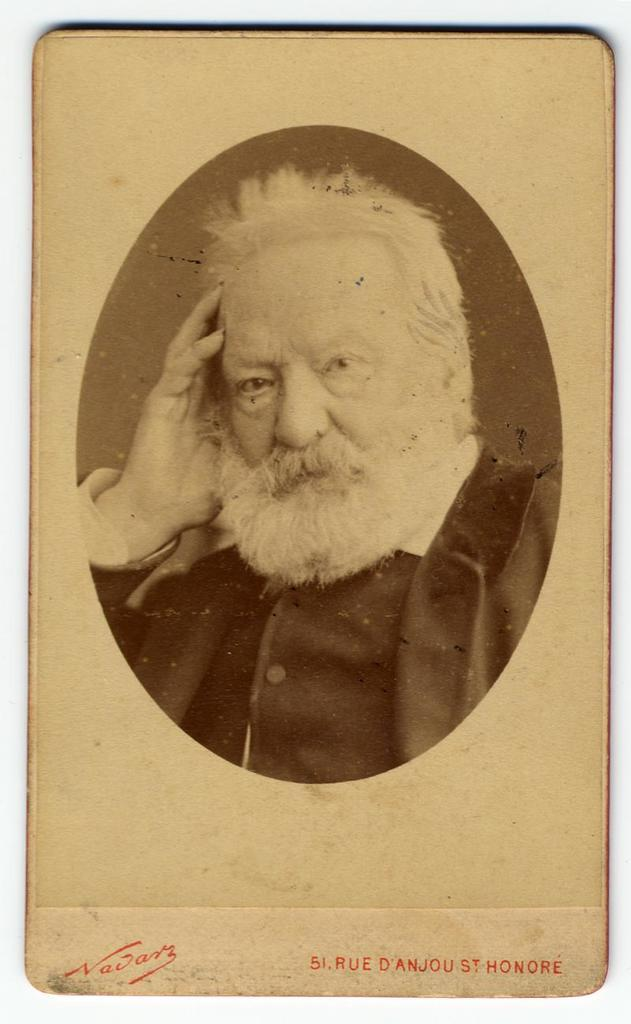What is the main subject of the image? The main subject of the image is a picture of a man. What is located under the picture of the man? There is text under the picture of the man. What type of alley is visible in the background of the image? There is no alley visible in the image; it only contains a picture of a man and text underneath. 